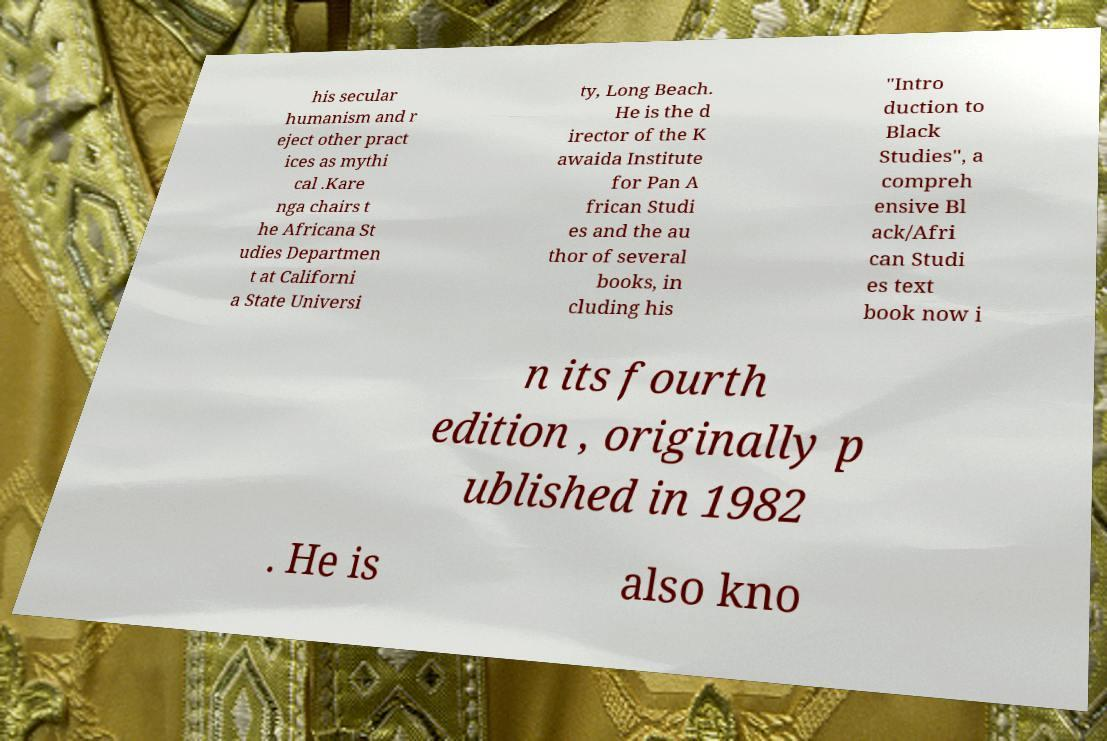Can you accurately transcribe the text from the provided image for me? his secular humanism and r eject other pract ices as mythi cal .Kare nga chairs t he Africana St udies Departmen t at Californi a State Universi ty, Long Beach. He is the d irector of the K awaida Institute for Pan A frican Studi es and the au thor of several books, in cluding his "Intro duction to Black Studies", a compreh ensive Bl ack/Afri can Studi es text book now i n its fourth edition , originally p ublished in 1982 . He is also kno 